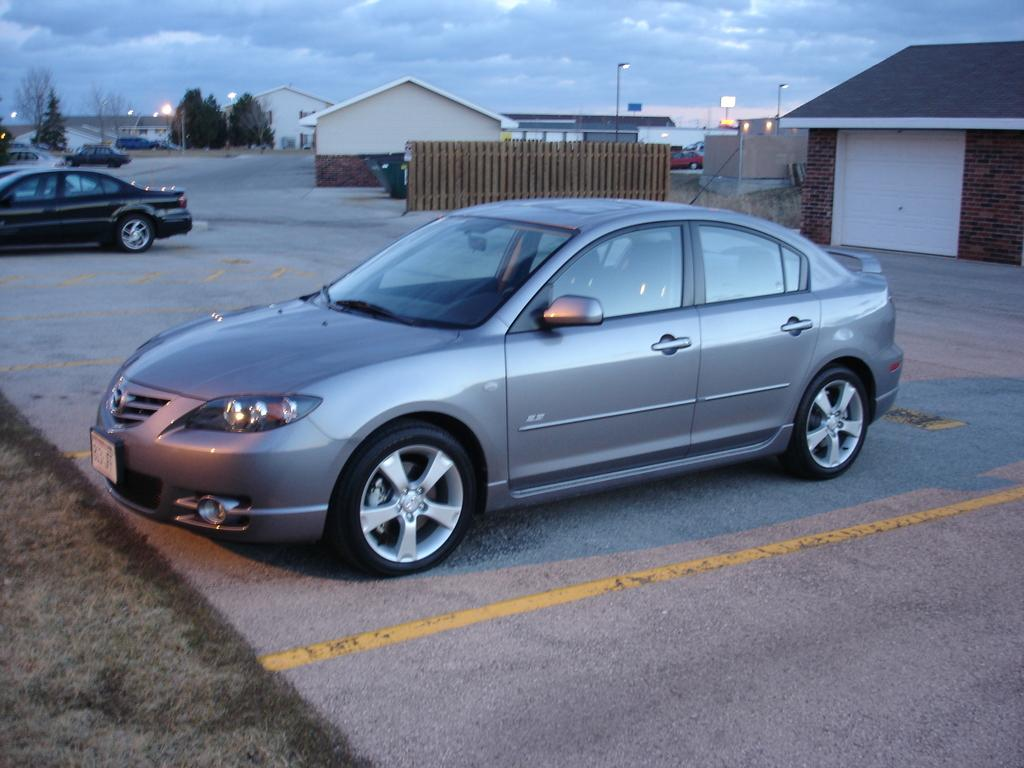What can be seen in front of the houses in the image? There are cars parked in front of the houses. What type of lighting is present beside the houses? There are pole lights beside the houses. What can be seen in the background of the image? There are many trees in the background. How many nails are used to hold the laborer's sign in the image? There is no laborer or sign present in the image, so it is not possible to determine the number of nails used. What type of pies are being sold by the vendor in the image? There is no vendor or pies present in the image, so it is not possible to determine what type of pies might be sold. 